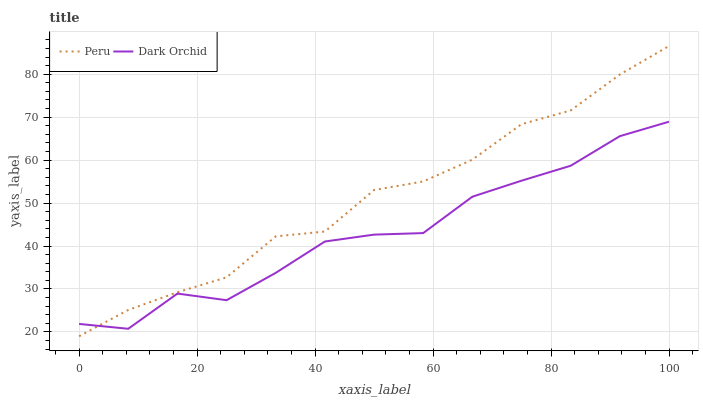Does Dark Orchid have the minimum area under the curve?
Answer yes or no. Yes. Does Peru have the maximum area under the curve?
Answer yes or no. Yes. Does Peru have the minimum area under the curve?
Answer yes or no. No. Is Peru the smoothest?
Answer yes or no. Yes. Is Dark Orchid the roughest?
Answer yes or no. Yes. Is Peru the roughest?
Answer yes or no. No. Does Peru have the lowest value?
Answer yes or no. Yes. Does Peru have the highest value?
Answer yes or no. Yes. Does Dark Orchid intersect Peru?
Answer yes or no. Yes. Is Dark Orchid less than Peru?
Answer yes or no. No. Is Dark Orchid greater than Peru?
Answer yes or no. No. 